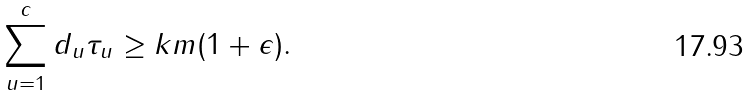<formula> <loc_0><loc_0><loc_500><loc_500>\sum _ { { u = } 1 } ^ { c } d _ { u } \tau _ { u } \geq k m ( 1 + \epsilon ) .</formula> 